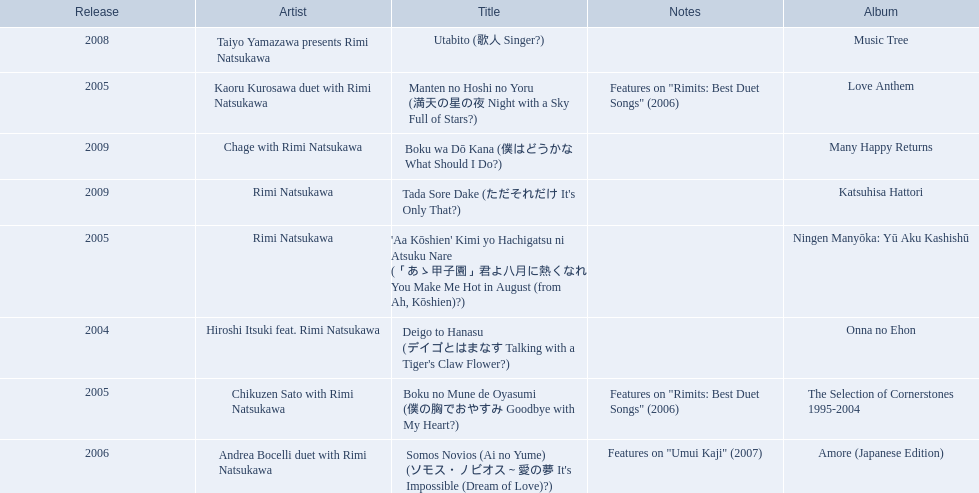When was onna no ehon released? 2004. When was the selection of cornerstones 1995-2004 released? 2005. What was released in 2008? Music Tree. 